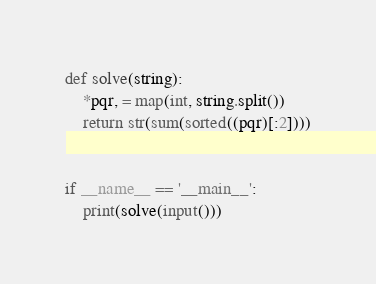<code> <loc_0><loc_0><loc_500><loc_500><_Python_>def solve(string):
    *pqr, = map(int, string.split())
    return str(sum(sorted((pqr)[:2])))


if __name__ == '__main__':
    print(solve(input()))
</code> 